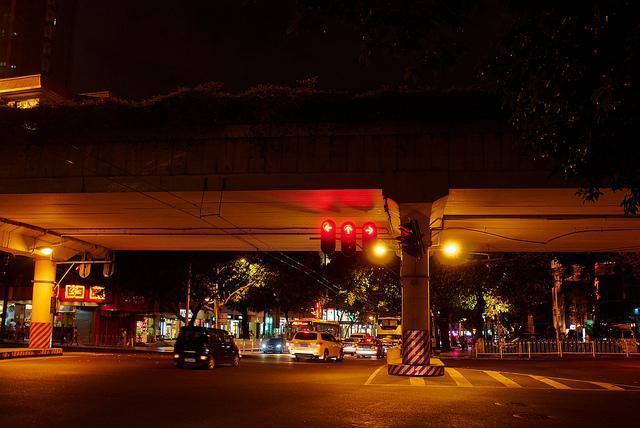How many red lights are shown?
Give a very brief answer. 3. How many cars are in the photo?
Give a very brief answer. 1. How many cows a man is holding?
Give a very brief answer. 0. 